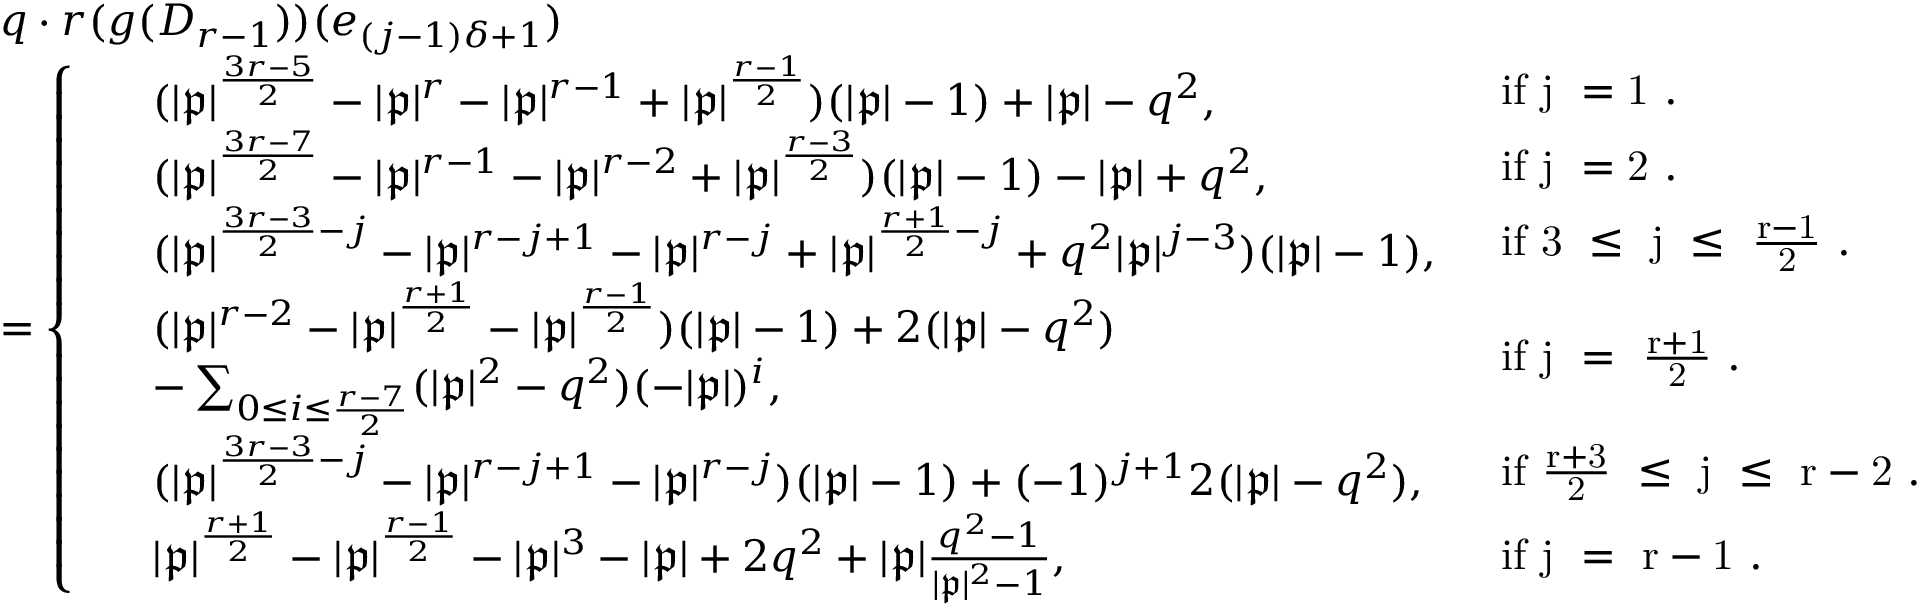Convert formula to latex. <formula><loc_0><loc_0><loc_500><loc_500>\begin{array} { r l } & { q \cdot r ( g ( D _ { r - 1 } ) ) ( e _ { ( j - 1 ) \delta + 1 } ) } \\ & { = \left \{ \begin{array} { l l } { \, \begin{array} { r l } & { ( | \mathfrak { p } | ^ { \frac { 3 r - 5 } { 2 } } - | \mathfrak { p } | ^ { r } - | \mathfrak { p } | ^ { r - 1 } + | \mathfrak { p } | ^ { \frac { r - 1 } { 2 } } ) ( | \mathfrak { p } | - 1 ) + | \mathfrak { p } | - q ^ { 2 } , } \end{array} } & { i f j = 1 . } \\ { \, \begin{array} { r l } & { ( | \mathfrak { p } | ^ { \frac { 3 r - 7 } { 2 } } - | \mathfrak { p } | ^ { r - 1 } - | \mathfrak { p } | ^ { r - 2 } + | \mathfrak { p } | ^ { \frac { r - 3 } { 2 } } ) ( | \mathfrak { p } | - 1 ) - | \mathfrak { p } | + q ^ { 2 } , } \end{array} } & { i f j = 2 . } \\ { \, \begin{array} { r l } & { ( | \mathfrak { p } | ^ { \frac { 3 r - 3 } { 2 } - j } - | \mathfrak { p } | ^ { r - j + 1 } - | \mathfrak { p } | ^ { r - j } + | \mathfrak { p } | ^ { \frac { r + 1 } { 2 } - j } + q ^ { 2 } | \mathfrak { p } | ^ { j - 3 } ) ( | \mathfrak { p } | - 1 ) , } \end{array} } & { i f 3 \leq j \leq \frac { r - 1 } { 2 } . } \\ { \, \begin{array} { r l } & { ( | \mathfrak { p } | ^ { r - 2 } - | \mathfrak { p } | ^ { \frac { r + 1 } { 2 } } - | \mathfrak { p } | ^ { \frac { r - 1 } { 2 } } ) ( | \mathfrak { p } | - 1 ) + 2 ( | \mathfrak { p } | - q ^ { 2 } ) } \\ & { - \sum _ { 0 \leq i \leq \frac { r - 7 } { 2 } } ( | \mathfrak { p } | ^ { 2 } - q ^ { 2 } ) ( - | \mathfrak { p } | ) ^ { i } , } \end{array} } & { i f j = \frac { r + 1 } { 2 } . } \\ { \, \begin{array} { r l } & { ( | \mathfrak { p } | ^ { \frac { 3 r - 3 } { 2 } - j } - | \mathfrak { p } | ^ { r - j + 1 } - | \mathfrak { p } | ^ { r - j } ) ( | \mathfrak { p } | - 1 ) + ( - 1 ) ^ { j + 1 } 2 ( | \mathfrak { p } | - q ^ { 2 } ) , } \end{array} } & { i f \frac { r + 3 } { 2 } \leq j \leq r - 2 . } \\ { \, \begin{array} { r l } & { | \mathfrak { p } | ^ { \frac { r + 1 } { 2 } } - | \mathfrak { p } | ^ { \frac { r - 1 } { 2 } } - | \mathfrak { p } | ^ { 3 } - | \mathfrak { p } | + 2 q ^ { 2 } + | \mathfrak { p } | \frac { q ^ { 2 } - 1 } { | \mathfrak { p } | ^ { 2 } - 1 } , } \end{array} } & { i f j = r - 1 . } \end{array} } \end{array}</formula> 